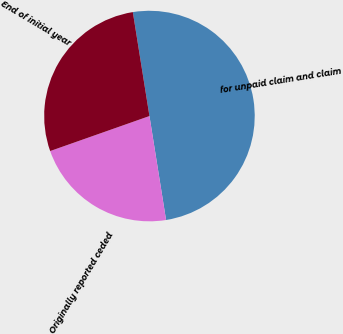Convert chart to OTSL. <chart><loc_0><loc_0><loc_500><loc_500><pie_chart><fcel>for unpaid claim and claim<fcel>Originally reported ceded<fcel>End of initial year<nl><fcel>50.0%<fcel>22.13%<fcel>27.87%<nl></chart> 